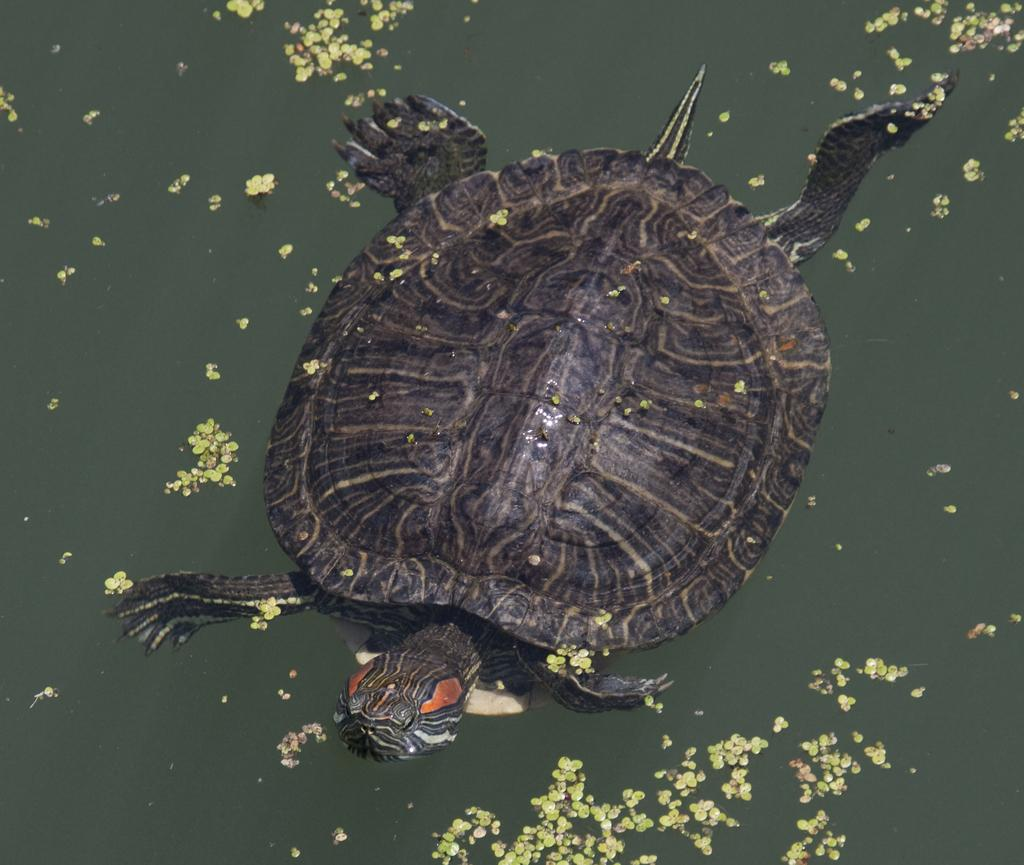What is the primary element in the image? There is water in the image. What animal can be seen in the water? A tortoise is swimming in the water. Reasoning: Let's think step by identifying the main subjects and objects in the image based on the provided facts. We then formulate questions that focus on the location and characteristics of these subjects and objects, ensuring that each question can be answered definitively with the information given. We avoid yes/no questions and ensure that the language is simple and clear. Absurd Question/Answer: What type of treatment is the tortoise receiving at the seashore in the image? There is no seashore present in the image, and the tortoise is not receiving any treatment. How many apples can be seen in the image? There are no apples present in the image. How many apples can be seen in the image? There are no apples present in the image. 